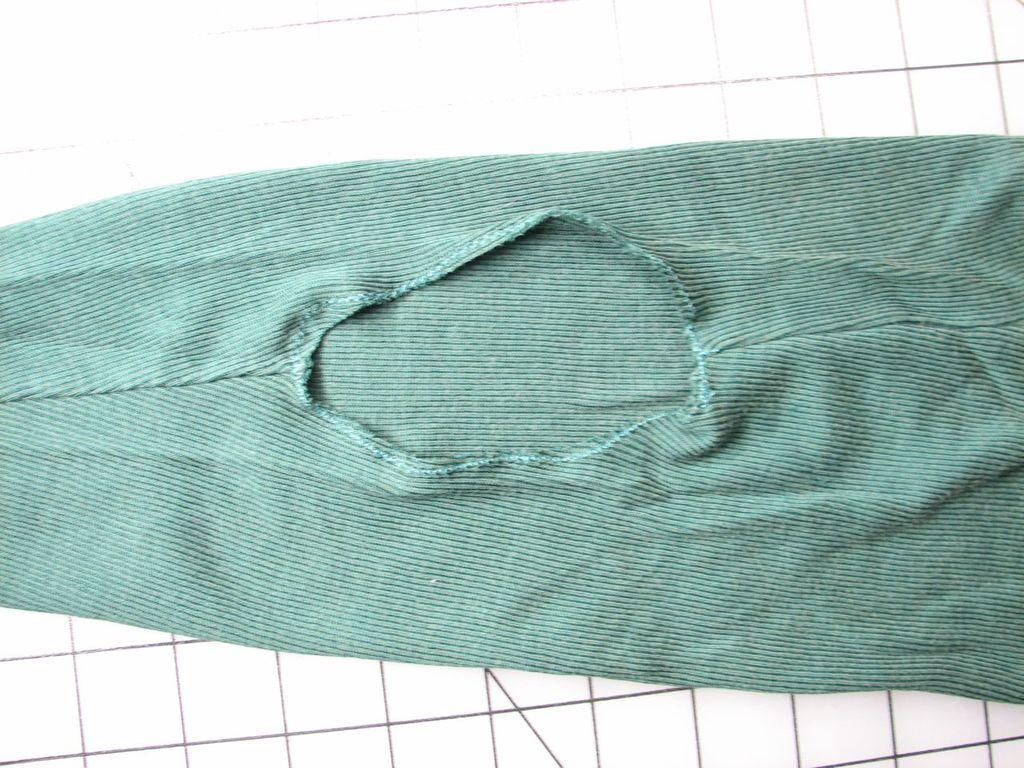Describe this image in one or two sentences. In this image I can see a blue color cloth. It is on the white and black color floor. 